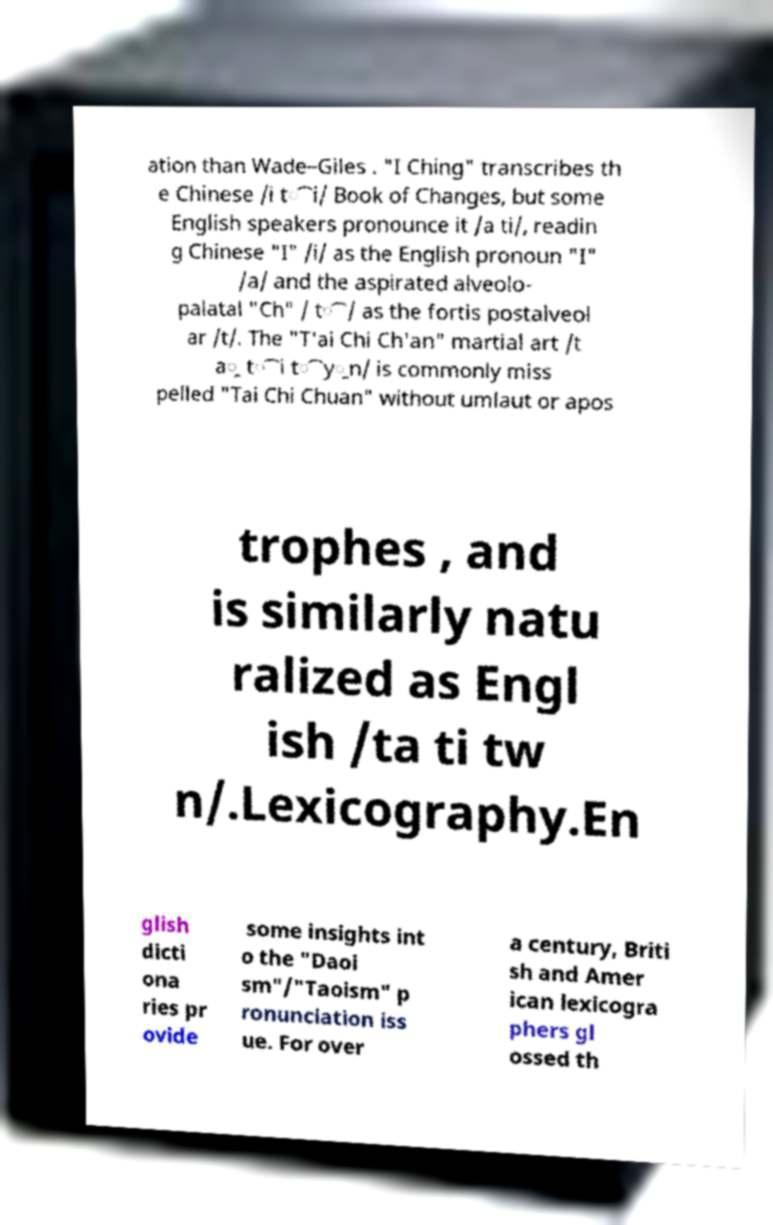For documentation purposes, I need the text within this image transcribed. Could you provide that? ation than Wade–Giles . "I Ching" transcribes th e Chinese /i t͡i/ Book of Changes, but some English speakers pronounce it /a ti/, readin g Chinese "I" /i/ as the English pronoun "I" /a/ and the aspirated alveolo- palatal "Ch" / t͡/ as the fortis postalveol ar /t/. The "T'ai Chi Ch'an" martial art /t a̯ t͡i t͡y̯n/ is commonly miss pelled "Tai Chi Chuan" without umlaut or apos trophes , and is similarly natu ralized as Engl ish /ta ti tw n/.Lexicography.En glish dicti ona ries pr ovide some insights int o the "Daoi sm"/"Taoism" p ronunciation iss ue. For over a century, Briti sh and Amer ican lexicogra phers gl ossed th 